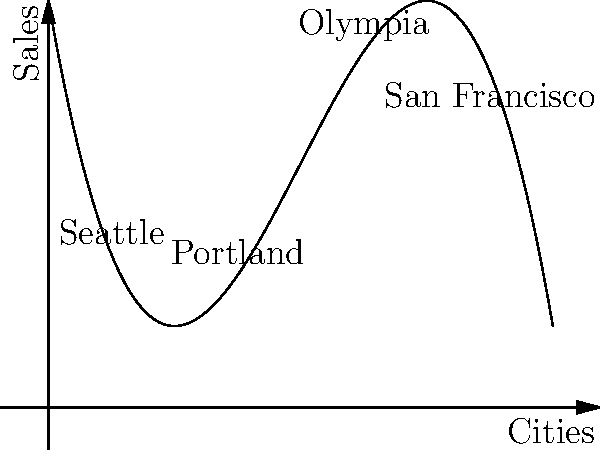The graph above represents the sales trajectory of a Riot grrrl zine across different cities, modeled by the polynomial function $f(x) = -0.5x^3 + 6x^2 - 18x + 20$. In which city does the zine reach its peak sales, and what is the approximate maximum number of sales? To find the peak sales and the city where it occurs, we need to follow these steps:

1) The maximum point of the function occurs where its derivative equals zero. Let's find the derivative:
   $f'(x) = -1.5x^2 + 12x - 18$

2) Set the derivative to zero and solve for x:
   $-1.5x^2 + 12x - 18 = 0$
   $-3x^2 + 24x - 36 = 0$
   $-3(x^2 - 8x + 12) = 0$
   $-3(x - 6)(x - 2) = 0$
   $x = 6$ or $x = 2$

3) The second derivative $f''(x) = -3x + 12$ is negative when $x = 6$ and positive when $x = 2$, so the maximum occurs at $x = 6$.

4) Looking at the graph, $x = 6$ corresponds to a point between Olympia and San Francisco, closer to Olympia.

5) To find the maximum sales, we evaluate $f(6)$:
   $f(6) = -0.5(6^3) + 6(6^2) - 18(6) + 20$
   $= -108 + 216 - 108 + 20$
   $= 20$

Therefore, the peak sales occur closest to Olympia, with approximately 20 zines sold.
Answer: Olympia; 20 zines 